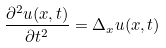Convert formula to latex. <formula><loc_0><loc_0><loc_500><loc_500>\frac { \partial ^ { 2 } u ( x , t ) } { \partial t ^ { 2 } } = \Delta _ { x } u ( x , t )</formula> 